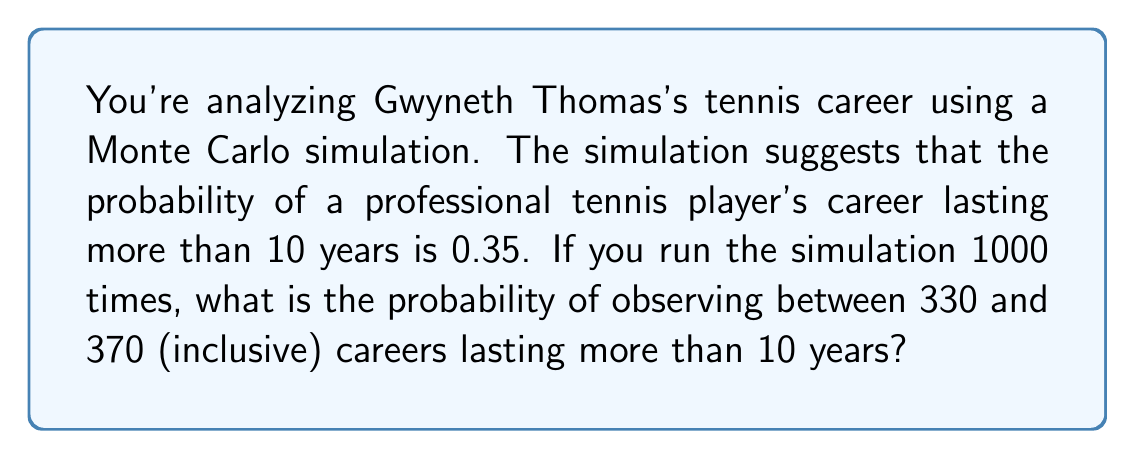Show me your answer to this math problem. Let's approach this step-by-step:

1) This scenario follows a binomial distribution. Each simulation is a Bernoulli trial with probability of success $p = 0.35$.

2) The number of trials is $n = 1000$.

3) We want to find $P(330 \leq X \leq 370)$, where $X$ is the number of successes.

4) For large $n$ and $np > 5$, we can approximate the binomial distribution with a normal distribution:

   $X \sim N(np, \sqrt{np(1-p)})$

5) Calculate the mean ($\mu$) and standard deviation ($\sigma$):
   
   $\mu = np = 1000 * 0.35 = 350$
   $\sigma = \sqrt{np(1-p)} = \sqrt{1000 * 0.35 * 0.65} = \sqrt{227.5} \approx 15.08$

6) Standardize the interval bounds:
   
   $z_{lower} = \frac{330 - 350}{15.08} \approx -1.33$
   $z_{upper} = \frac{370 - 350}{15.08} \approx 1.33$

7) Use the standard normal distribution to calculate:

   $P(330 \leq X \leq 370) \approx P(-1.33 \leq Z \leq 1.33)$

8) Using a standard normal table or calculator:

   $P(-1.33 \leq Z \leq 1.33) = P(Z \leq 1.33) - P(Z \leq -1.33)$
                                $= 0.9082 - 0.0918$
                                $= 0.8164$

Therefore, the probability is approximately 0.8164 or 81.64%.
Answer: 0.8164 